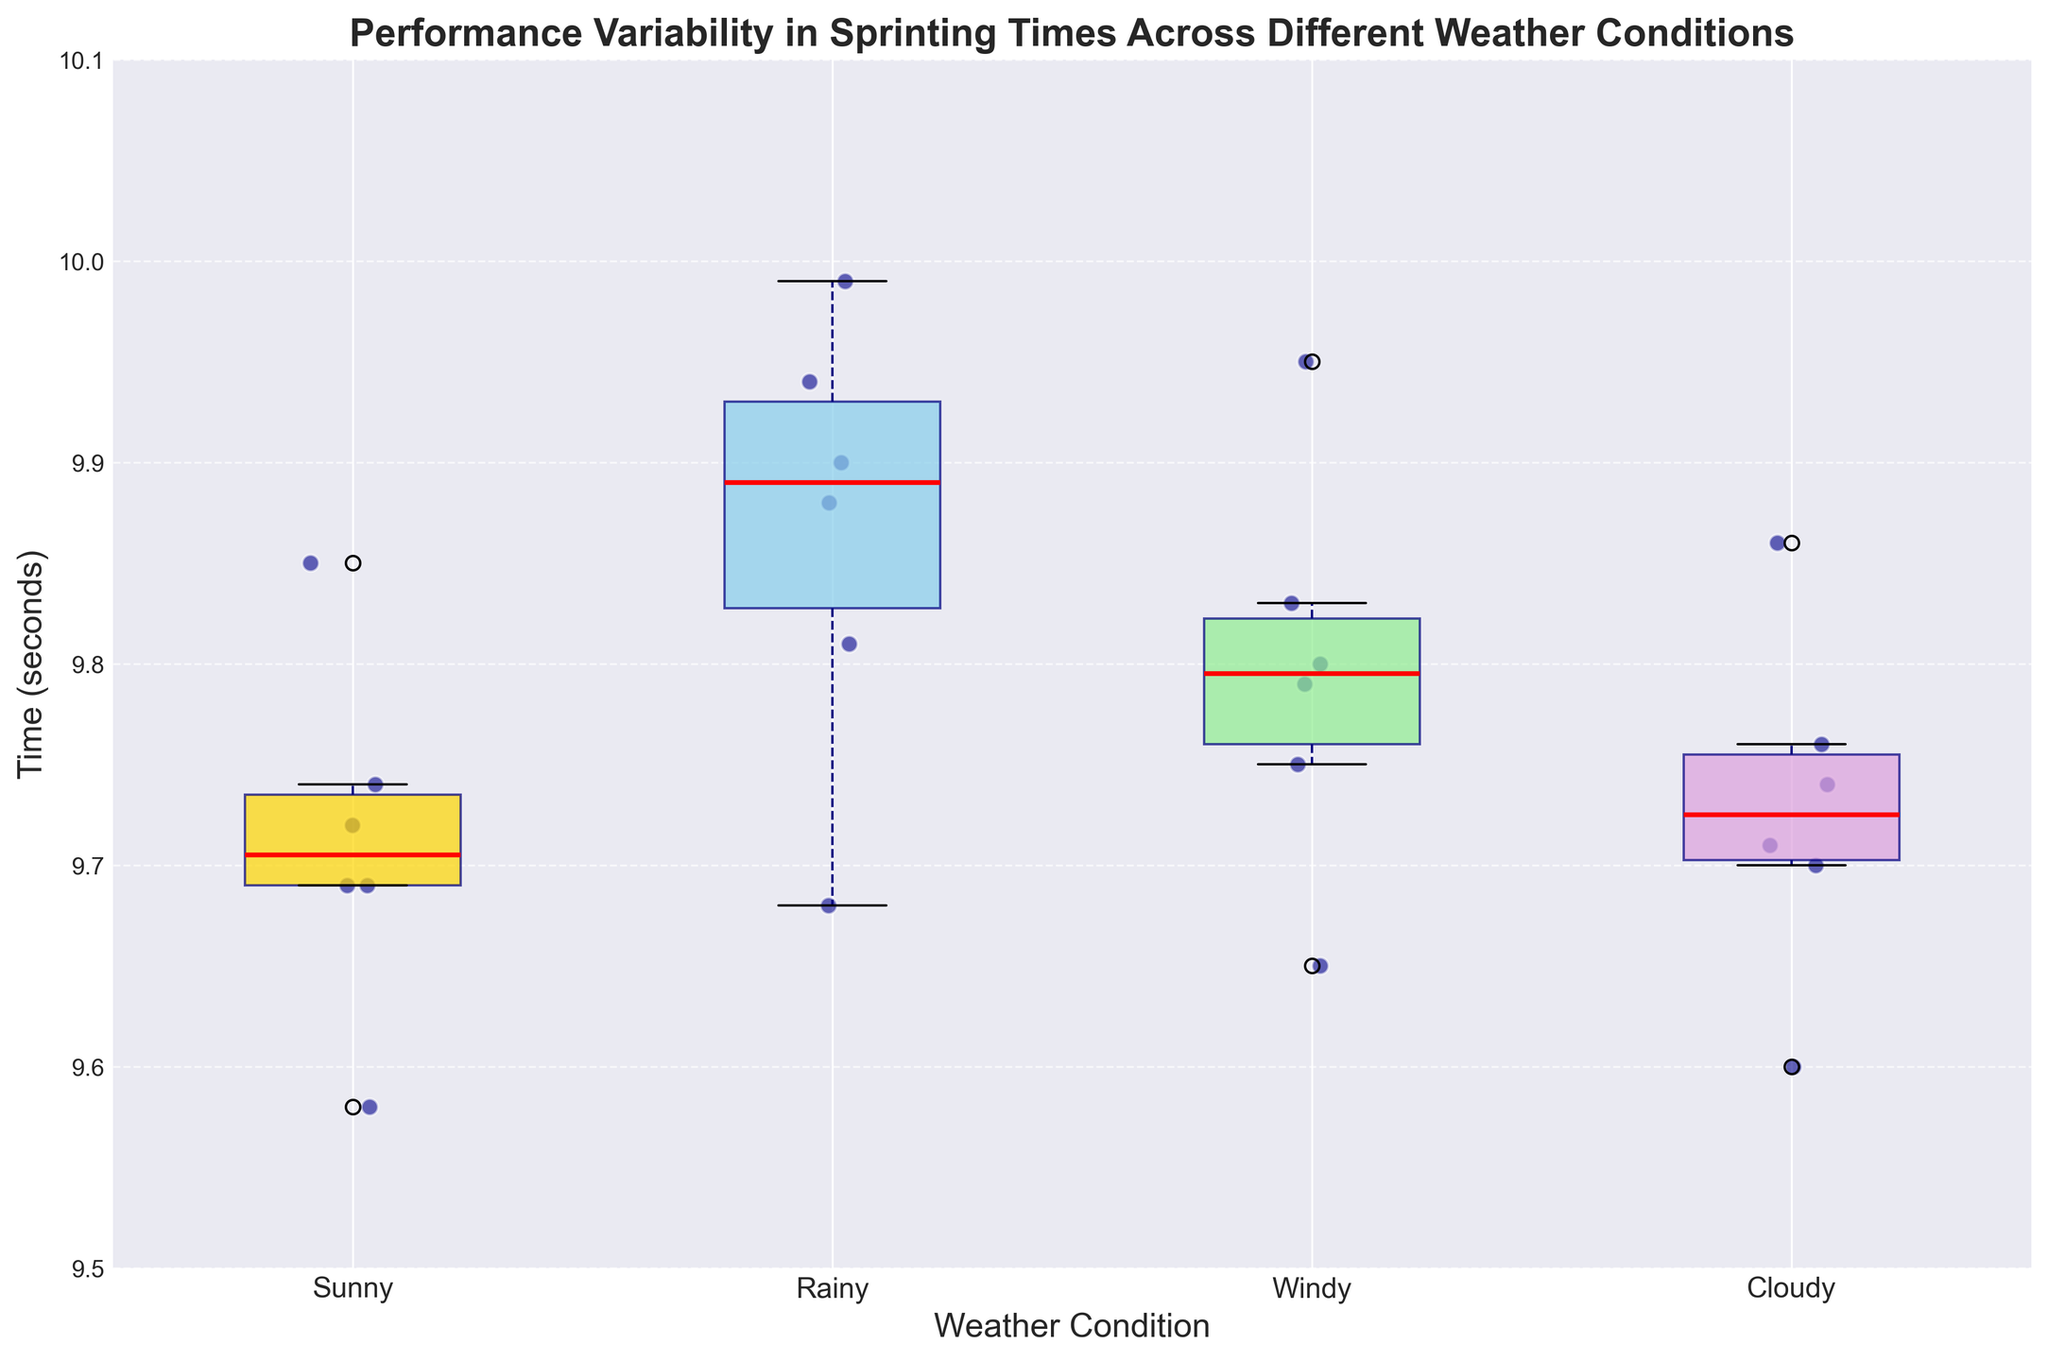What is the title of the figure? The title is prominently displayed at the top of the figure and provides a summary of what the chart represents.
Answer: Performance Variability in Sprinting Times Across Different Weather Conditions What are the different weather conditions shown in the figure? The x-axis has labels that denote the different weather conditions studied.
Answer: Sunny, Rainy, Windy, Cloudy What does the y-axis represent in this figure? The y-axis label indicates the variable being measured in the figure.
Answer: Time (seconds) Which weather condition has the smallest median sprinting time? The median is represented by the red line inside each box in the box plot. The box plot for Sunny weather has the lowest red line.
Answer: Sunny Which weather condition shows the highest variability in sprinting times? Variability is indicated by the length between the top and bottom whiskers of each box plot. The Rainy condition has the longest whiskers.
Answer: Rainy How does Usain Bolt's performance vary across the different weather conditions? You need to locate the scatter points corresponding to Usain Bolt in each boxplot and note his times. They are 9.58, 9.68, 9.65, and 9.60 for Sunny, Rainy, Windy, and Cloudy, respectively.
Answer: Slight variation, generally low times Which sprinter has the most consistent performance across all weather conditions? Consistent performance can be deduced by finding the sprinter whose points have the least spread across weather conditions. Yohan Blake's times are 9.69, 9.81, 9.75, 9.70, showing minimal spread.
Answer: Yohan Blake What is the difference between the median sprinting times on Sunny and Rainy days? Identify the median lines on Sunny and Rainy days. The medians are 9.70 and 9.88 seconds respectively. The difference is 9.88 - 9.70.
Answer: 0.18 seconds Which weather condition has the closest overall sprinting times? The box plot with the smallest interquartile range (the box length) indicates that the overall sprinting times are the closest. The plot for Windy weather has the smallest box width.
Answer: Windy What are the upper and lower whiskers for the Cloudy weather condition? The upper and lower whiskers are the ends of the dashed lines extending from the box. For Cloudy, these correspond to 9.86 (top) and 9.60 (bottom).
Answer: Upper: 9.86, Lower: 9.60 